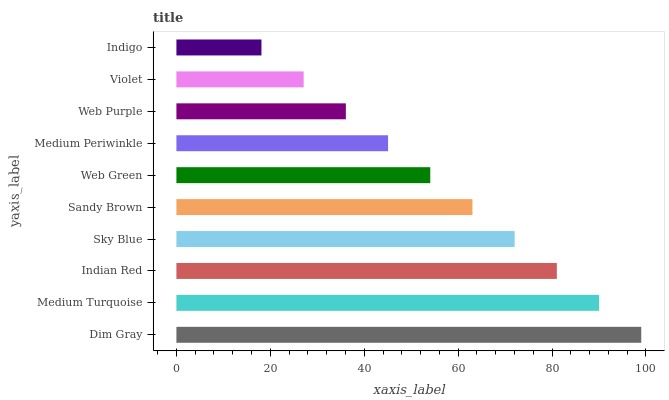Is Indigo the minimum?
Answer yes or no. Yes. Is Dim Gray the maximum?
Answer yes or no. Yes. Is Medium Turquoise the minimum?
Answer yes or no. No. Is Medium Turquoise the maximum?
Answer yes or no. No. Is Dim Gray greater than Medium Turquoise?
Answer yes or no. Yes. Is Medium Turquoise less than Dim Gray?
Answer yes or no. Yes. Is Medium Turquoise greater than Dim Gray?
Answer yes or no. No. Is Dim Gray less than Medium Turquoise?
Answer yes or no. No. Is Sandy Brown the high median?
Answer yes or no. Yes. Is Web Green the low median?
Answer yes or no. Yes. Is Medium Periwinkle the high median?
Answer yes or no. No. Is Violet the low median?
Answer yes or no. No. 